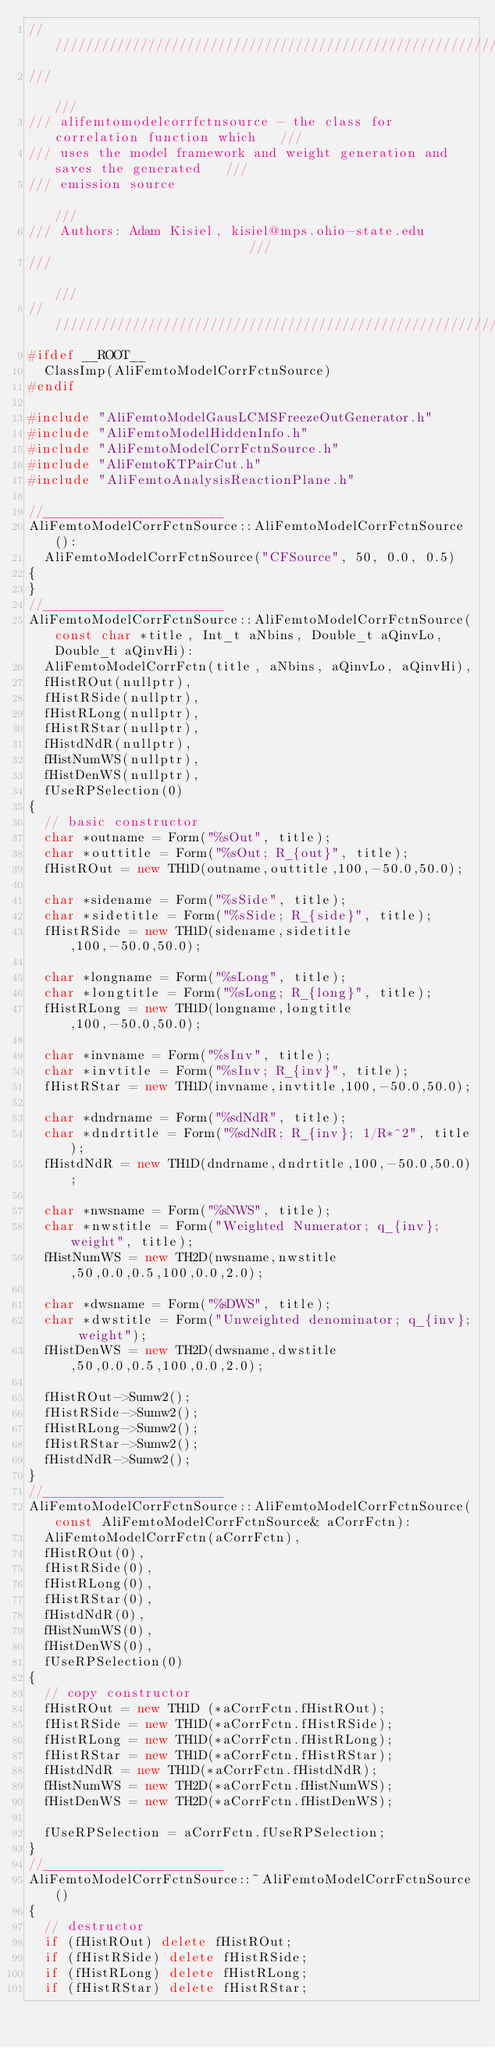<code> <loc_0><loc_0><loc_500><loc_500><_C++_>////////////////////////////////////////////////////////////////////////////////
///                                                                          ///
/// alifemtomodelcorrfctnsource - the class for correlation function which   ///
/// uses the model framework and weight generation and saves the generated   ///
/// emission source                                                          ///
/// Authors: Adam Kisiel, kisiel@mps.ohio-state.edu                          ///
///                                                                          ///
////////////////////////////////////////////////////////////////////////////////
#ifdef __ROOT__
  ClassImp(AliFemtoModelCorrFctnSource)
#endif

#include "AliFemtoModelGausLCMSFreezeOutGenerator.h"
#include "AliFemtoModelHiddenInfo.h"
#include "AliFemtoModelCorrFctnSource.h"
#include "AliFemtoKTPairCut.h"
#include "AliFemtoAnalysisReactionPlane.h"

//_______________________
AliFemtoModelCorrFctnSource::AliFemtoModelCorrFctnSource():
  AliFemtoModelCorrFctnSource("CFSource", 50, 0.0, 0.5)
{
}
//_______________________
AliFemtoModelCorrFctnSource::AliFemtoModelCorrFctnSource(const char *title, Int_t aNbins, Double_t aQinvLo, Double_t aQinvHi):
  AliFemtoModelCorrFctn(title, aNbins, aQinvLo, aQinvHi),
  fHistROut(nullptr),
  fHistRSide(nullptr),
  fHistRLong(nullptr),
  fHistRStar(nullptr),
  fHistdNdR(nullptr),
  fHistNumWS(nullptr),
  fHistDenWS(nullptr),
  fUseRPSelection(0)
{
  // basic constructor
  char *outname = Form("%sOut", title);
  char *outtitle = Form("%sOut; R_{out}", title);
  fHistROut = new TH1D(outname,outtitle,100,-50.0,50.0);

  char *sidename = Form("%sSide", title);
  char *sidetitle = Form("%sSide; R_{side}", title);
  fHistRSide = new TH1D(sidename,sidetitle,100,-50.0,50.0);

  char *longname = Form("%sLong", title);
  char *longtitle = Form("%sLong; R_{long}", title);
  fHistRLong = new TH1D(longname,longtitle,100,-50.0,50.0);

  char *invname = Form("%sInv", title);
  char *invtitle = Form("%sInv; R_{inv}", title);
  fHistRStar = new TH1D(invname,invtitle,100,-50.0,50.0);

  char *dndrname = Form("%sdNdR", title);
  char *dndrtitle = Form("%sdNdR; R_{inv}; 1/R*^2", title);
  fHistdNdR = new TH1D(dndrname,dndrtitle,100,-50.0,50.0);

  char *nwsname = Form("%sNWS", title);
  char *nwstitle = Form("Weighted Numerator; q_{inv}; weight", title);
  fHistNumWS = new TH2D(nwsname,nwstitle,50,0.0,0.5,100,0.0,2.0);

  char *dwsname = Form("%sDWS", title);
  char *dwstitle = Form("Unweighted denominator; q_{inv}; weight");
  fHistDenWS = new TH2D(dwsname,dwstitle,50,0.0,0.5,100,0.0,2.0);

  fHistROut->Sumw2();
  fHistRSide->Sumw2();
  fHistRLong->Sumw2();
  fHistRStar->Sumw2();
  fHistdNdR->Sumw2();
}
//_______________________
AliFemtoModelCorrFctnSource::AliFemtoModelCorrFctnSource(const AliFemtoModelCorrFctnSource& aCorrFctn):
  AliFemtoModelCorrFctn(aCorrFctn),
  fHistROut(0),
  fHistRSide(0),
  fHistRLong(0),
  fHistRStar(0),
  fHistdNdR(0),
  fHistNumWS(0),
  fHistDenWS(0),
  fUseRPSelection(0)
{
  // copy constructor
  fHistROut = new TH1D (*aCorrFctn.fHistROut);
  fHistRSide = new TH1D(*aCorrFctn.fHistRSide);
  fHistRLong = new TH1D(*aCorrFctn.fHistRLong);
  fHistRStar = new TH1D(*aCorrFctn.fHistRStar);
  fHistdNdR = new TH1D(*aCorrFctn.fHistdNdR);
  fHistNumWS = new TH2D(*aCorrFctn.fHistNumWS);
  fHistDenWS = new TH2D(*aCorrFctn.fHistDenWS);

  fUseRPSelection = aCorrFctn.fUseRPSelection;
}
//_______________________
AliFemtoModelCorrFctnSource::~AliFemtoModelCorrFctnSource()
{
  // destructor
  if (fHistROut) delete fHistROut;
  if (fHistRSide) delete fHistRSide;
  if (fHistRLong) delete fHistRLong;
  if (fHistRStar) delete fHistRStar;</code> 